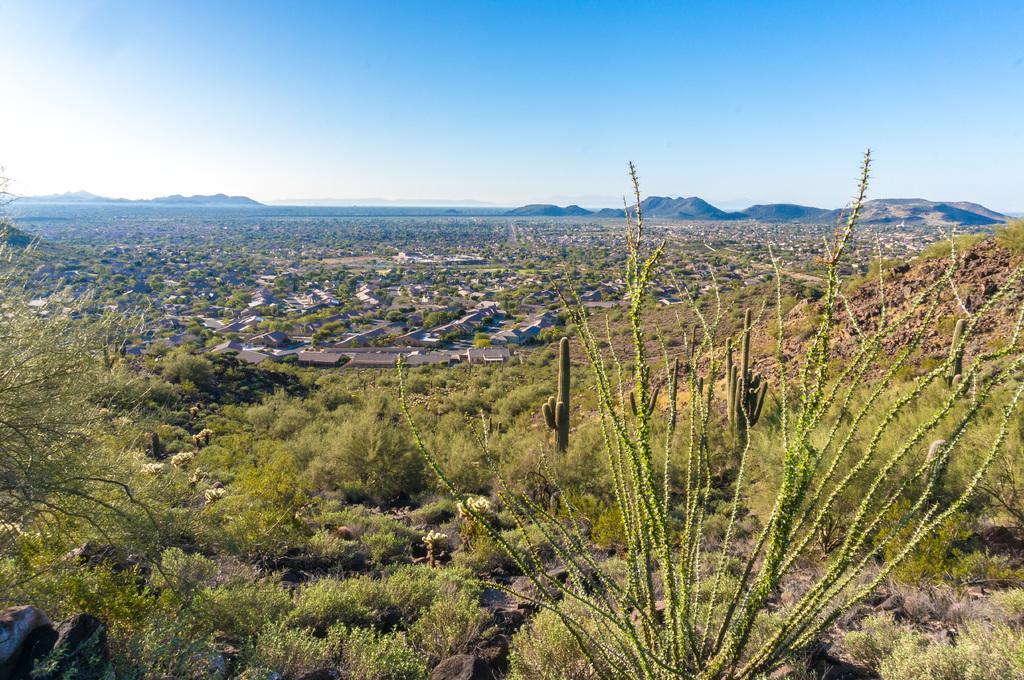Could you give a brief overview of what you see in this image? In the background we can see the sky, hills. In this picture we can see the houses, rooftops, trees and plants. 